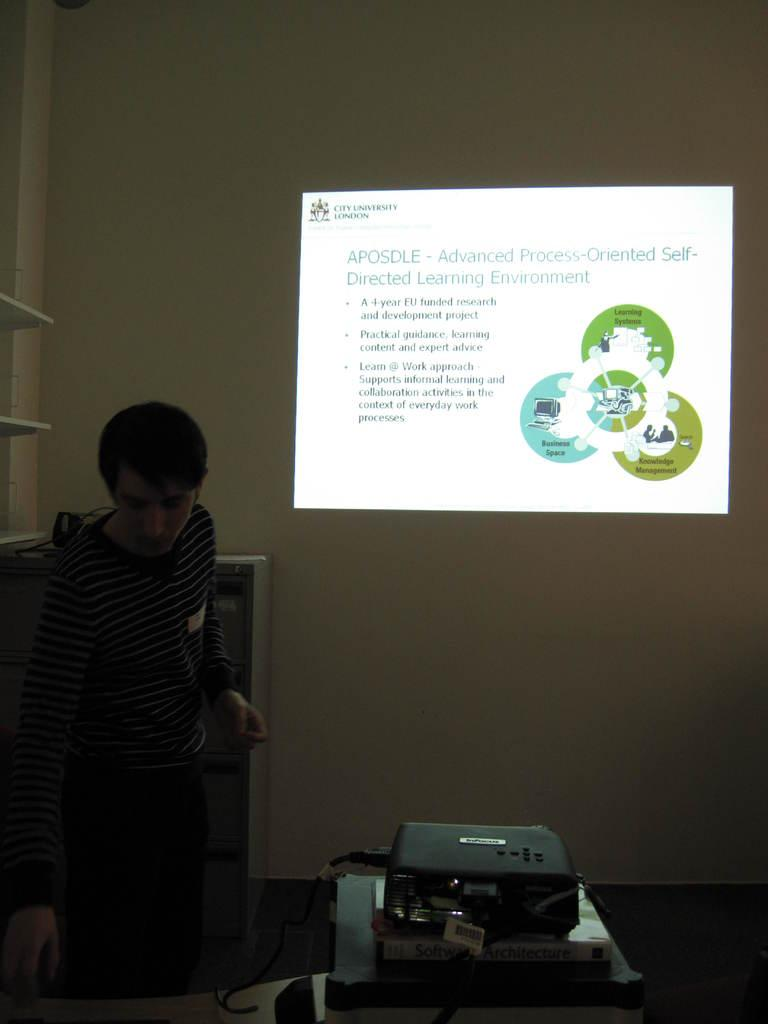What is the main subject in the image? There is a man standing in the image. Where is the man standing? The man is standing on the floor. What can be seen in the image besides the man? There is a projector, bookshelves, a screen on the wall, and some objects in the image. What type of comb is the man using to guide the goose in the image? There is no goose or comb present in the image. 